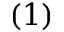Convert formula to latex. <formula><loc_0><loc_0><loc_500><loc_500>( 1 )</formula> 